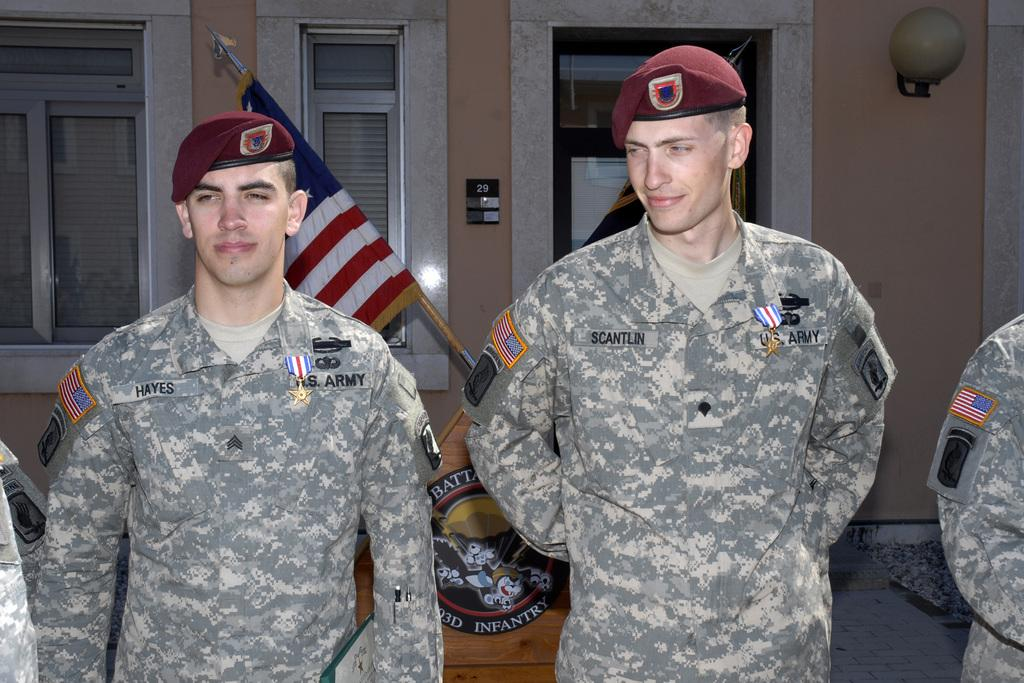<image>
Render a clear and concise summary of the photo. a person standing with others and one name saying scantlin on it 